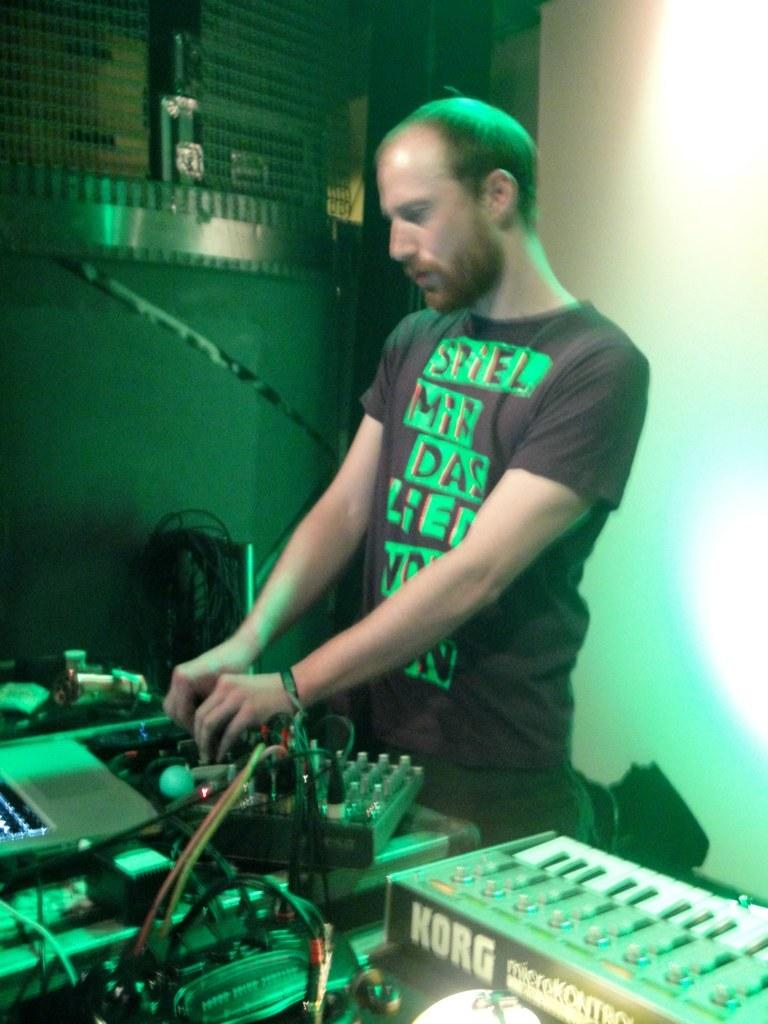What is the main subject of the image? There is a person standing in the image. What can be seen at the bottom of the image? There are machines, wires, and a piano at the bottom of the image. What is present in the background of the image? There is a wall in the background of the image. What other object can be seen in the image? There is a grill in the image. What type of nut is being used to adjust the rate of the machines in the image? There is no nut or mention of adjusting the rate of machines in the image. 